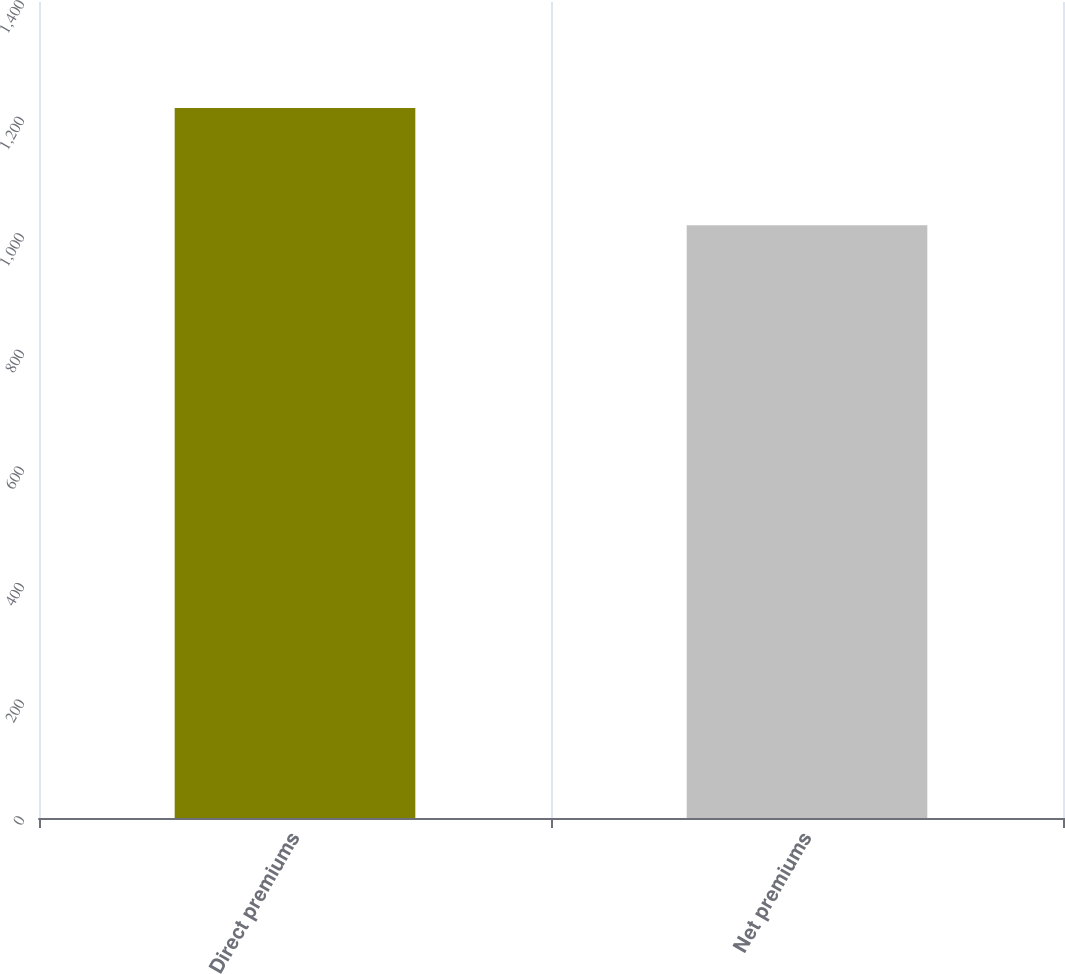<chart> <loc_0><loc_0><loc_500><loc_500><bar_chart><fcel>Direct premiums<fcel>Net premiums<nl><fcel>1218<fcel>1017<nl></chart> 